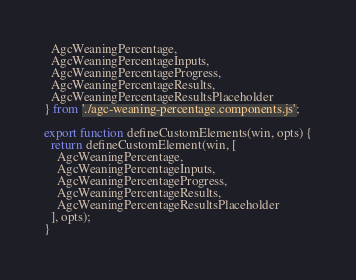Convert code to text. <code><loc_0><loc_0><loc_500><loc_500><_JavaScript_>  AgcWeaningPercentage,
  AgcWeaningPercentageInputs,
  AgcWeaningPercentageProgress,
  AgcWeaningPercentageResults,
  AgcWeaningPercentageResultsPlaceholder
} from './agc-weaning-percentage.components.js';

export function defineCustomElements(win, opts) {
  return defineCustomElement(win, [
    AgcWeaningPercentage,
    AgcWeaningPercentageInputs,
    AgcWeaningPercentageProgress,
    AgcWeaningPercentageResults,
    AgcWeaningPercentageResultsPlaceholder
  ], opts);
}
</code> 